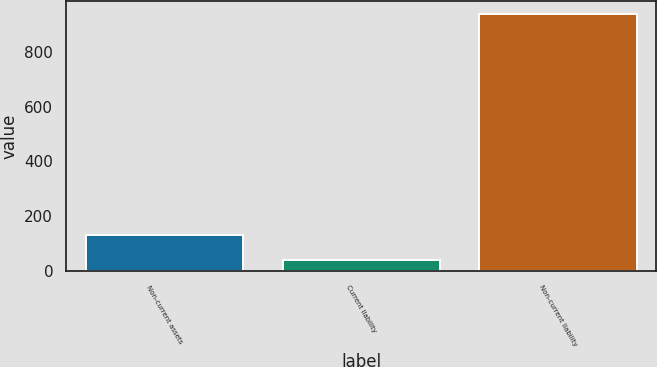<chart> <loc_0><loc_0><loc_500><loc_500><bar_chart><fcel>Non-current assets<fcel>Current liability<fcel>Non-current liability<nl><fcel>131.5<fcel>42<fcel>937<nl></chart> 